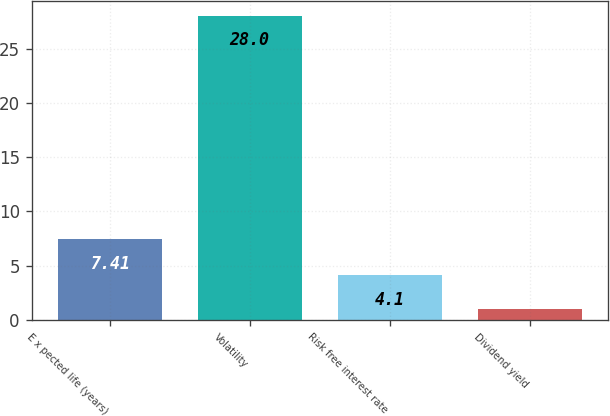Convert chart. <chart><loc_0><loc_0><loc_500><loc_500><bar_chart><fcel>E x pected life (years)<fcel>Volatility<fcel>Risk free interest rate<fcel>Dividend yield<nl><fcel>7.41<fcel>28<fcel>4.1<fcel>0.98<nl></chart> 